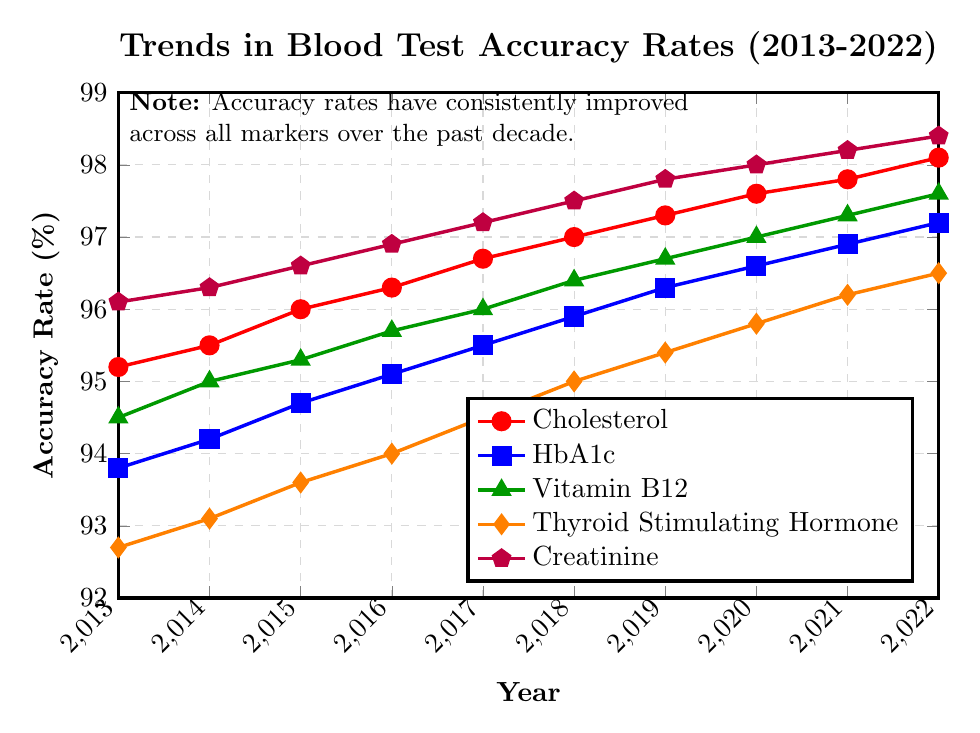What is the overall trend in blood test accuracy rates for Cholesterol from 2013 to 2022? The accuracy rate for Cholesterol shows a consistent increase from 95.2% in 2013 to 98.1% in 2022. This indicates an overall improvement in Cholesterol test accuracy over the past decade.
Answer: Increasing Which marker had the highest accuracy rate in 2022? In 2022, the Creatinine marker had the highest accuracy rate at 98.4%.
Answer: Creatinine Compare the accuracy rates of Cholesterol and Thyroid Stimulating Hormone in 2017. Which one was higher and by how much? In 2017, the accuracy rate for Cholesterol was 96.7% and for Thyroid Stimulating Hormone was 94.5%. The accuracy rate for Cholesterol was higher by 96.7% - 94.5% = 2.2%.
Answer: Cholesterol, 2.2% What is the average accuracy rate for HbA1c over the entire decade? The accuracy rates for HbA1c from 2013 to 2022 are: 93.8, 94.2, 94.7, 95.1, 95.5, 95.9, 96.3, 96.6, 96.9, 97.2 respectively. The sum of these values is 956.2. Thus, the average accuracy rate is 956.2 / 10 = 95.62%.
Answer: 95.62% Which marker shows the smallest absolute improvement in accuracy rate from 2013 to 2022? To find the smallest improvement, we calculate the increase for each marker:
- Cholesterol: 98.1 - 95.2 = 2.9%
- HbA1c: 97.2 - 93.8 = 3.4%
- Vitamin B12: 97.6 - 94.5 = 3.1%
- Thyroid Stimulating Hormone: 96.5 - 92.7 = 3.8%
- Creatinine: 98.4 - 96.1 = 2.3%
The smallest improvement is for the Creatinine marker (2.3%).
Answer: Creatinine How did the accuracy rate for Vitamin B12 change from 2018 to 2020? The accuracy rate for Vitamin B12 in 2018 was 96.4% and it increased to 97.0% in 2020. This is an increase of 97.0% - 96.4% = 0.6%.
Answer: Increased by 0.6% According to the plot, which marker had the lowest accuracy rate in 2015? In 2015, the Thyroid Stimulating Hormone marker had the lowest accuracy rate at 93.6%.
Answer: Thyroid Stimulating Hormone How many years did it take for the HbA1c accuracy rate to increase from below 95% to above 96%? The HbA1c accuracy rate was below 95% in 2015 (94.7%). It reached above 96% in 2019 (96.3%), hence it took from 2015 to 2019, which is 4 years.
Answer: 4 years 